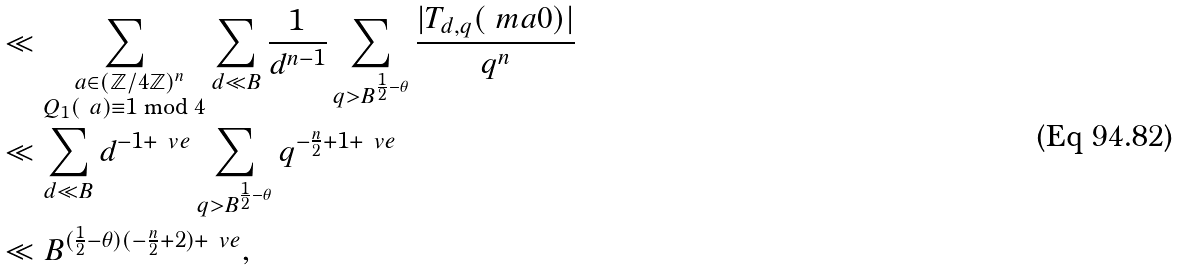<formula> <loc_0><loc_0><loc_500><loc_500>& \ll \sum _ { \substack { \ a \in ( \mathbb { Z } / 4 \mathbb { Z } ) ^ { n } \\ Q _ { 1 } ( \ a ) \equiv 1 \bmod { 4 } } } \sum _ { d \ll B } \frac { 1 } { d ^ { n - 1 } } \sum _ { q > B ^ { \frac { 1 } { 2 } - \theta } } \frac { | T _ { d , q } ( \ m a { 0 } ) | } { q ^ { n } } \\ & \ll \sum _ { d \ll B } d ^ { - 1 + \ v e } \sum _ { q > B ^ { \frac { 1 } { 2 } - \theta } } q ^ { - \frac { n } { 2 } + 1 + \ v e } \\ & \ll B ^ { ( \frac { 1 } { 2 } - \theta ) ( - \frac { n } { 2 } + 2 ) + \ v e } ,</formula> 